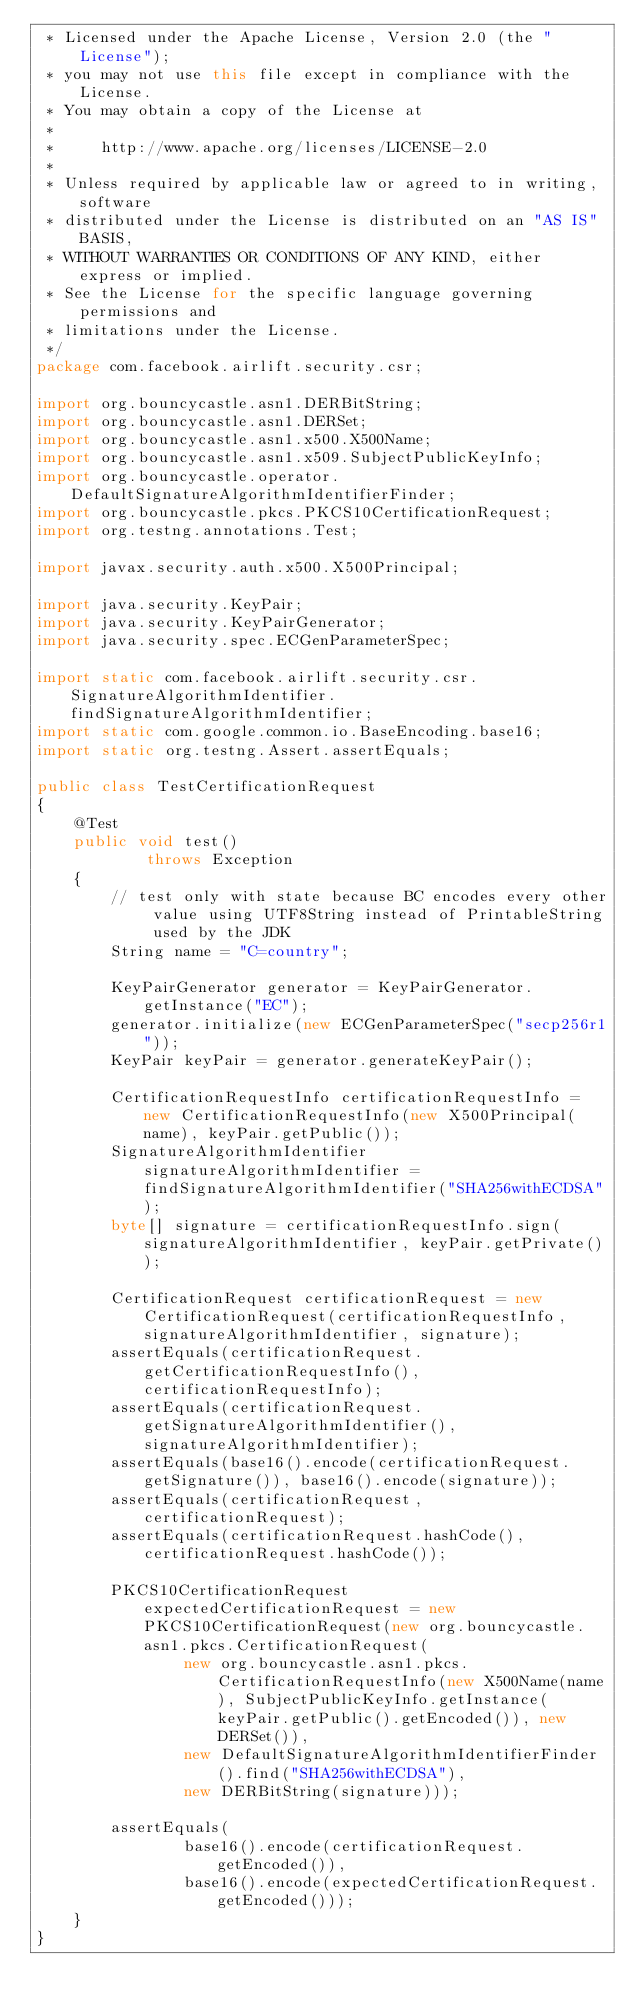Convert code to text. <code><loc_0><loc_0><loc_500><loc_500><_Java_> * Licensed under the Apache License, Version 2.0 (the "License");
 * you may not use this file except in compliance with the License.
 * You may obtain a copy of the License at
 *
 *     http://www.apache.org/licenses/LICENSE-2.0
 *
 * Unless required by applicable law or agreed to in writing, software
 * distributed under the License is distributed on an "AS IS" BASIS,
 * WITHOUT WARRANTIES OR CONDITIONS OF ANY KIND, either express or implied.
 * See the License for the specific language governing permissions and
 * limitations under the License.
 */
package com.facebook.airlift.security.csr;

import org.bouncycastle.asn1.DERBitString;
import org.bouncycastle.asn1.DERSet;
import org.bouncycastle.asn1.x500.X500Name;
import org.bouncycastle.asn1.x509.SubjectPublicKeyInfo;
import org.bouncycastle.operator.DefaultSignatureAlgorithmIdentifierFinder;
import org.bouncycastle.pkcs.PKCS10CertificationRequest;
import org.testng.annotations.Test;

import javax.security.auth.x500.X500Principal;

import java.security.KeyPair;
import java.security.KeyPairGenerator;
import java.security.spec.ECGenParameterSpec;

import static com.facebook.airlift.security.csr.SignatureAlgorithmIdentifier.findSignatureAlgorithmIdentifier;
import static com.google.common.io.BaseEncoding.base16;
import static org.testng.Assert.assertEquals;

public class TestCertificationRequest
{
    @Test
    public void test()
            throws Exception
    {
        // test only with state because BC encodes every other value using UTF8String instead of PrintableString used by the JDK
        String name = "C=country";

        KeyPairGenerator generator = KeyPairGenerator.getInstance("EC");
        generator.initialize(new ECGenParameterSpec("secp256r1"));
        KeyPair keyPair = generator.generateKeyPair();

        CertificationRequestInfo certificationRequestInfo = new CertificationRequestInfo(new X500Principal(name), keyPair.getPublic());
        SignatureAlgorithmIdentifier signatureAlgorithmIdentifier = findSignatureAlgorithmIdentifier("SHA256withECDSA");
        byte[] signature = certificationRequestInfo.sign(signatureAlgorithmIdentifier, keyPair.getPrivate());

        CertificationRequest certificationRequest = new CertificationRequest(certificationRequestInfo, signatureAlgorithmIdentifier, signature);
        assertEquals(certificationRequest.getCertificationRequestInfo(), certificationRequestInfo);
        assertEquals(certificationRequest.getSignatureAlgorithmIdentifier(), signatureAlgorithmIdentifier);
        assertEquals(base16().encode(certificationRequest.getSignature()), base16().encode(signature));
        assertEquals(certificationRequest, certificationRequest);
        assertEquals(certificationRequest.hashCode(), certificationRequest.hashCode());

        PKCS10CertificationRequest expectedCertificationRequest = new PKCS10CertificationRequest(new org.bouncycastle.asn1.pkcs.CertificationRequest(
                new org.bouncycastle.asn1.pkcs.CertificationRequestInfo(new X500Name(name), SubjectPublicKeyInfo.getInstance(keyPair.getPublic().getEncoded()), new DERSet()),
                new DefaultSignatureAlgorithmIdentifierFinder().find("SHA256withECDSA"),
                new DERBitString(signature)));

        assertEquals(
                base16().encode(certificationRequest.getEncoded()),
                base16().encode(expectedCertificationRequest.getEncoded()));
    }
}
</code> 